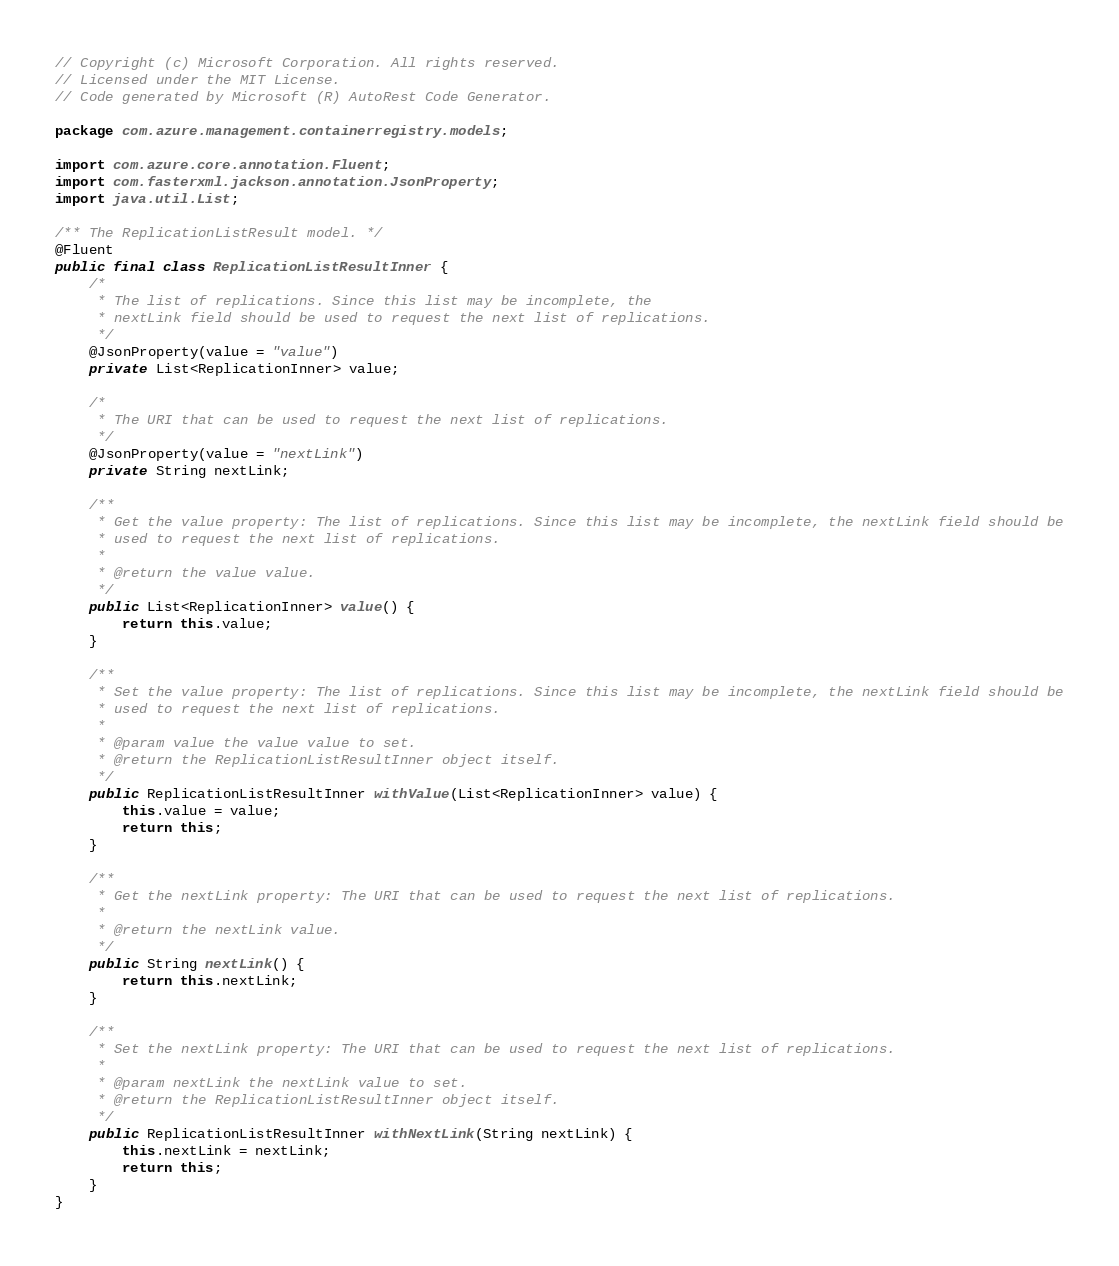Convert code to text. <code><loc_0><loc_0><loc_500><loc_500><_Java_>// Copyright (c) Microsoft Corporation. All rights reserved.
// Licensed under the MIT License.
// Code generated by Microsoft (R) AutoRest Code Generator.

package com.azure.management.containerregistry.models;

import com.azure.core.annotation.Fluent;
import com.fasterxml.jackson.annotation.JsonProperty;
import java.util.List;

/** The ReplicationListResult model. */
@Fluent
public final class ReplicationListResultInner {
    /*
     * The list of replications. Since this list may be incomplete, the
     * nextLink field should be used to request the next list of replications.
     */
    @JsonProperty(value = "value")
    private List<ReplicationInner> value;

    /*
     * The URI that can be used to request the next list of replications.
     */
    @JsonProperty(value = "nextLink")
    private String nextLink;

    /**
     * Get the value property: The list of replications. Since this list may be incomplete, the nextLink field should be
     * used to request the next list of replications.
     *
     * @return the value value.
     */
    public List<ReplicationInner> value() {
        return this.value;
    }

    /**
     * Set the value property: The list of replications. Since this list may be incomplete, the nextLink field should be
     * used to request the next list of replications.
     *
     * @param value the value value to set.
     * @return the ReplicationListResultInner object itself.
     */
    public ReplicationListResultInner withValue(List<ReplicationInner> value) {
        this.value = value;
        return this;
    }

    /**
     * Get the nextLink property: The URI that can be used to request the next list of replications.
     *
     * @return the nextLink value.
     */
    public String nextLink() {
        return this.nextLink;
    }

    /**
     * Set the nextLink property: The URI that can be used to request the next list of replications.
     *
     * @param nextLink the nextLink value to set.
     * @return the ReplicationListResultInner object itself.
     */
    public ReplicationListResultInner withNextLink(String nextLink) {
        this.nextLink = nextLink;
        return this;
    }
}
</code> 